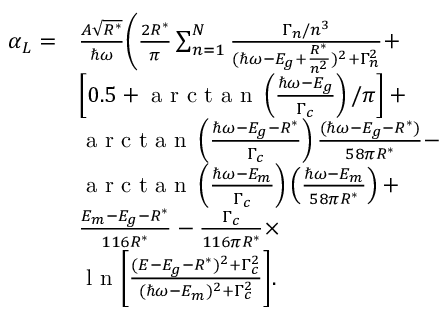<formula> <loc_0><loc_0><loc_500><loc_500>\begin{array} { r l } { \alpha _ { L } = } & { \frac { A \sqrt { R ^ { * } } } { \hbar { \omega } } \Big ( \frac { 2 R ^ { * } } { \pi } \sum _ { n = 1 } ^ { N } \frac { \Gamma _ { n } / n ^ { 3 } } { ( \hbar { \omega } - E _ { g } + \frac { R ^ { * } } { n ^ { 2 } } ) ^ { 2 } + \Gamma _ { n } ^ { 2 } } + } \\ & { \left [ 0 . 5 + a r c t a n \left ( \frac { \hbar { \omega } - E _ { g } } { \Gamma _ { c } } \right ) / \pi \right ] + } \\ & { a r c t a n \left ( \frac { \hbar { \omega } - E _ { g } - R ^ { * } } { \Gamma _ { c } } \right ) \frac { ( \hbar { \omega } - E _ { g } - R ^ { * } ) } { 5 8 \pi R ^ { * } } - } \\ & { a r c t a n \left ( \frac { \hbar { \omega } - E _ { m } } { \Gamma _ { c } } \right ) \left ( \frac { \hbar { \omega } - E _ { m } } { 5 8 \pi R ^ { * } } \right ) + } \\ & { \frac { E _ { m } - E _ { g } - R ^ { * } } { 1 1 6 R ^ { * } } - \frac { \Gamma _ { c } } { 1 1 6 \pi R ^ { * } } \times } \\ & { \ln \Big [ \frac { ( E - E _ { g } - R ^ { * } ) ^ { 2 } + \Gamma _ { c } ^ { 2 } } { ( \hbar { \omega } - E _ { m } ) ^ { 2 } + \Gamma _ { c } ^ { 2 } } \Big ] . } \end{array}</formula> 